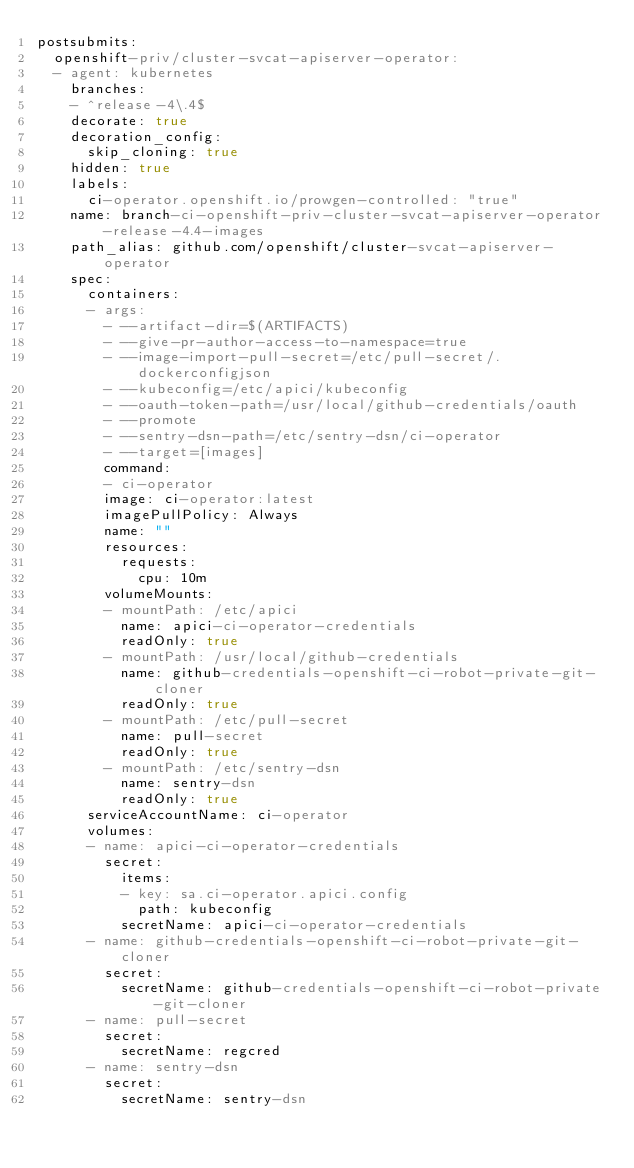<code> <loc_0><loc_0><loc_500><loc_500><_YAML_>postsubmits:
  openshift-priv/cluster-svcat-apiserver-operator:
  - agent: kubernetes
    branches:
    - ^release-4\.4$
    decorate: true
    decoration_config:
      skip_cloning: true
    hidden: true
    labels:
      ci-operator.openshift.io/prowgen-controlled: "true"
    name: branch-ci-openshift-priv-cluster-svcat-apiserver-operator-release-4.4-images
    path_alias: github.com/openshift/cluster-svcat-apiserver-operator
    spec:
      containers:
      - args:
        - --artifact-dir=$(ARTIFACTS)
        - --give-pr-author-access-to-namespace=true
        - --image-import-pull-secret=/etc/pull-secret/.dockerconfigjson
        - --kubeconfig=/etc/apici/kubeconfig
        - --oauth-token-path=/usr/local/github-credentials/oauth
        - --promote
        - --sentry-dsn-path=/etc/sentry-dsn/ci-operator
        - --target=[images]
        command:
        - ci-operator
        image: ci-operator:latest
        imagePullPolicy: Always
        name: ""
        resources:
          requests:
            cpu: 10m
        volumeMounts:
        - mountPath: /etc/apici
          name: apici-ci-operator-credentials
          readOnly: true
        - mountPath: /usr/local/github-credentials
          name: github-credentials-openshift-ci-robot-private-git-cloner
          readOnly: true
        - mountPath: /etc/pull-secret
          name: pull-secret
          readOnly: true
        - mountPath: /etc/sentry-dsn
          name: sentry-dsn
          readOnly: true
      serviceAccountName: ci-operator
      volumes:
      - name: apici-ci-operator-credentials
        secret:
          items:
          - key: sa.ci-operator.apici.config
            path: kubeconfig
          secretName: apici-ci-operator-credentials
      - name: github-credentials-openshift-ci-robot-private-git-cloner
        secret:
          secretName: github-credentials-openshift-ci-robot-private-git-cloner
      - name: pull-secret
        secret:
          secretName: regcred
      - name: sentry-dsn
        secret:
          secretName: sentry-dsn
</code> 